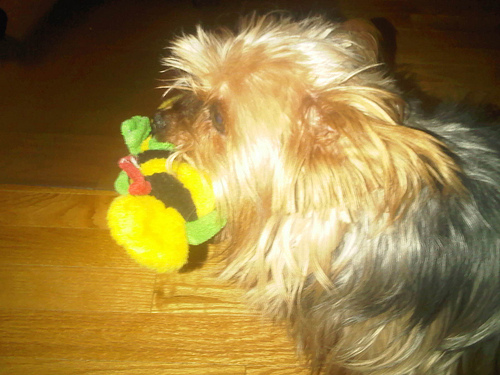<image>
Is the toy under the dog? Yes. The toy is positioned underneath the dog, with the dog above it in the vertical space. 